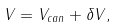Convert formula to latex. <formula><loc_0><loc_0><loc_500><loc_500>V = V _ { c a n } + \delta V ,</formula> 